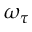<formula> <loc_0><loc_0><loc_500><loc_500>\omega _ { \tau }</formula> 